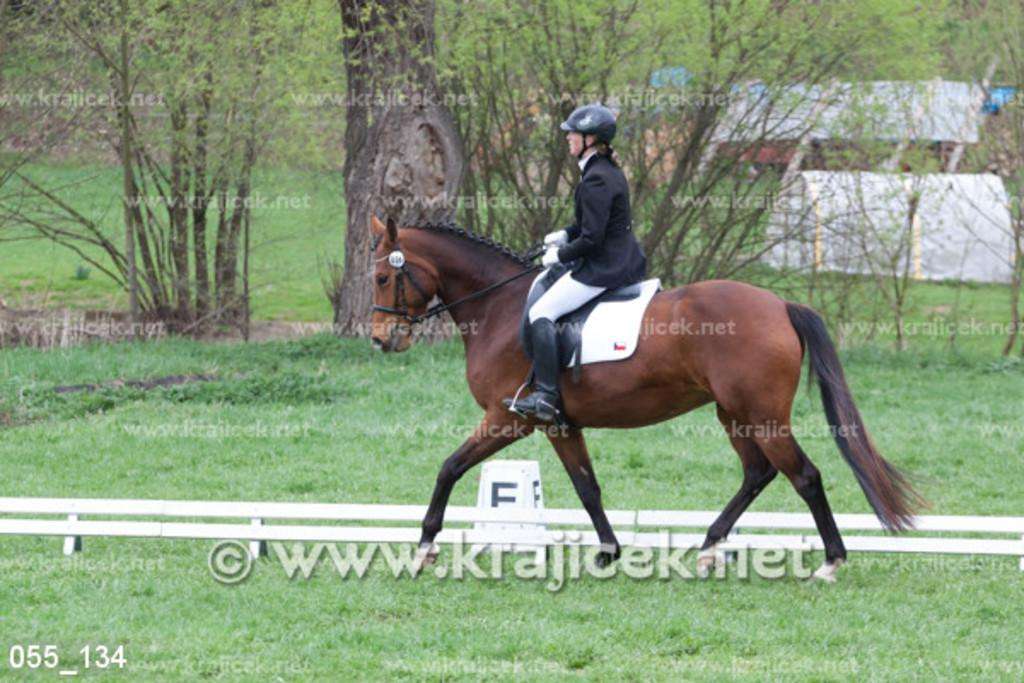What is the main subject of the image? There is a person riding a horse in the image. What can be seen in the background of the image? There are trees and grass in the image. Is there any obstacle or structure in the image? Yes, there is a barrier in the image. Can you describe any additional features of the image? There is a watermark in the image, and there are numbers in the bottom left corner of the image. What type of copper cap can be seen on the horse's head in the image? There is no copper cap present on the horse's head in the image. Can you tell me how many times the person riding the horse jumps over the barrier in the image? The image does not show the person riding the horse jumping over the barrier, so it is not possible to determine how many times they might have done so. 